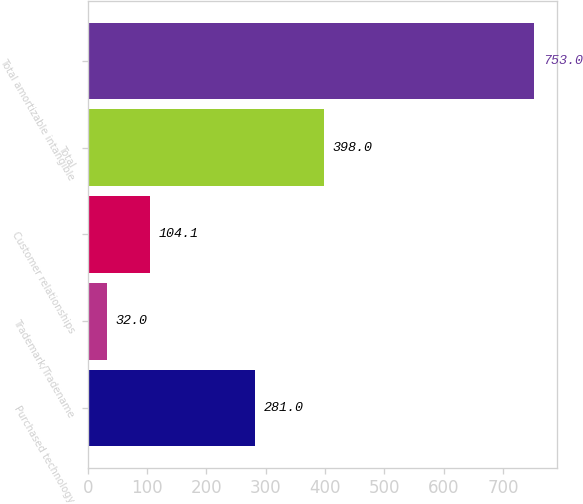Convert chart. <chart><loc_0><loc_0><loc_500><loc_500><bar_chart><fcel>Purchased technology<fcel>Trademark/Tradename<fcel>Customer relationships<fcel>Total<fcel>Total amortizable intangible<nl><fcel>281<fcel>32<fcel>104.1<fcel>398<fcel>753<nl></chart> 